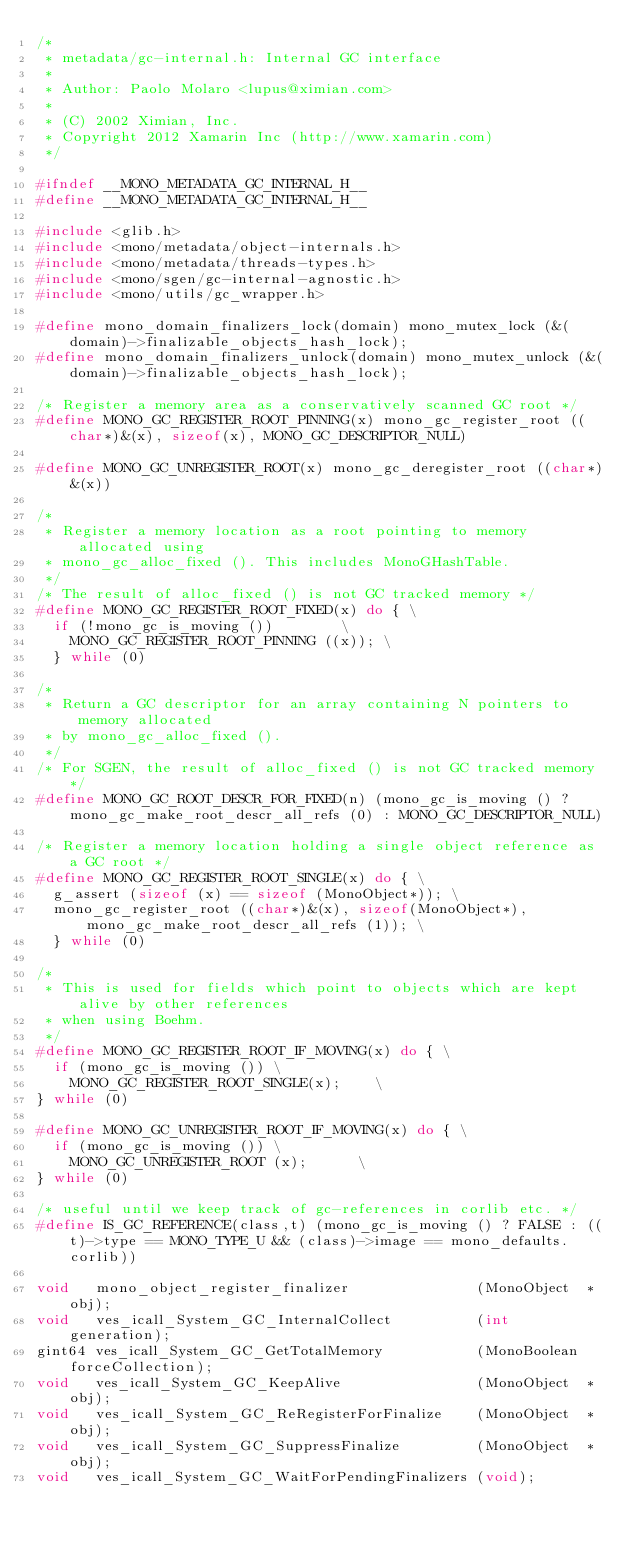<code> <loc_0><loc_0><loc_500><loc_500><_C_>/*
 * metadata/gc-internal.h: Internal GC interface
 *
 * Author: Paolo Molaro <lupus@ximian.com>
 *
 * (C) 2002 Ximian, Inc.
 * Copyright 2012 Xamarin Inc (http://www.xamarin.com)
 */

#ifndef __MONO_METADATA_GC_INTERNAL_H__
#define __MONO_METADATA_GC_INTERNAL_H__

#include <glib.h>
#include <mono/metadata/object-internals.h>
#include <mono/metadata/threads-types.h>
#include <mono/sgen/gc-internal-agnostic.h>
#include <mono/utils/gc_wrapper.h>

#define mono_domain_finalizers_lock(domain) mono_mutex_lock (&(domain)->finalizable_objects_hash_lock);
#define mono_domain_finalizers_unlock(domain) mono_mutex_unlock (&(domain)->finalizable_objects_hash_lock);

/* Register a memory area as a conservatively scanned GC root */
#define MONO_GC_REGISTER_ROOT_PINNING(x) mono_gc_register_root ((char*)&(x), sizeof(x), MONO_GC_DESCRIPTOR_NULL)

#define MONO_GC_UNREGISTER_ROOT(x) mono_gc_deregister_root ((char*)&(x))

/*
 * Register a memory location as a root pointing to memory allocated using
 * mono_gc_alloc_fixed (). This includes MonoGHashTable.
 */
/* The result of alloc_fixed () is not GC tracked memory */
#define MONO_GC_REGISTER_ROOT_FIXED(x) do { \
	if (!mono_gc_is_moving ())				\
		MONO_GC_REGISTER_ROOT_PINNING ((x)); \
	} while (0)

/*
 * Return a GC descriptor for an array containing N pointers to memory allocated
 * by mono_gc_alloc_fixed ().
 */
/* For SGEN, the result of alloc_fixed () is not GC tracked memory */
#define MONO_GC_ROOT_DESCR_FOR_FIXED(n) (mono_gc_is_moving () ? mono_gc_make_root_descr_all_refs (0) : MONO_GC_DESCRIPTOR_NULL)

/* Register a memory location holding a single object reference as a GC root */
#define MONO_GC_REGISTER_ROOT_SINGLE(x) do { \
	g_assert (sizeof (x) == sizeof (MonoObject*)); \
	mono_gc_register_root ((char*)&(x), sizeof(MonoObject*), mono_gc_make_root_descr_all_refs (1)); \
	} while (0)

/*
 * This is used for fields which point to objects which are kept alive by other references
 * when using Boehm.
 */
#define MONO_GC_REGISTER_ROOT_IF_MOVING(x) do { \
	if (mono_gc_is_moving ()) \
		MONO_GC_REGISTER_ROOT_SINGLE(x);		\
} while (0)

#define MONO_GC_UNREGISTER_ROOT_IF_MOVING(x) do { \
	if (mono_gc_is_moving ()) \
		MONO_GC_UNREGISTER_ROOT (x);			\
} while (0)

/* useful until we keep track of gc-references in corlib etc. */
#define IS_GC_REFERENCE(class,t) (mono_gc_is_moving () ? FALSE : ((t)->type == MONO_TYPE_U && (class)->image == mono_defaults.corlib))

void   mono_object_register_finalizer               (MonoObject  *obj);
void   ves_icall_System_GC_InternalCollect          (int          generation);
gint64 ves_icall_System_GC_GetTotalMemory           (MonoBoolean  forceCollection);
void   ves_icall_System_GC_KeepAlive                (MonoObject  *obj);
void   ves_icall_System_GC_ReRegisterForFinalize    (MonoObject  *obj);
void   ves_icall_System_GC_SuppressFinalize         (MonoObject  *obj);
void   ves_icall_System_GC_WaitForPendingFinalizers (void);
</code> 